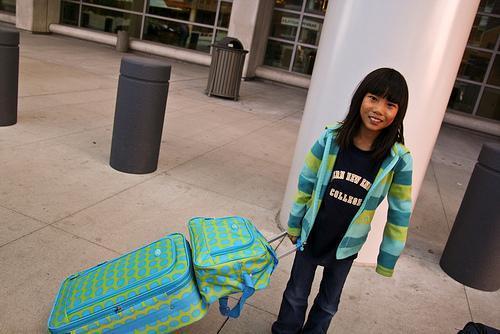How many people are there?
Give a very brief answer. 1. 